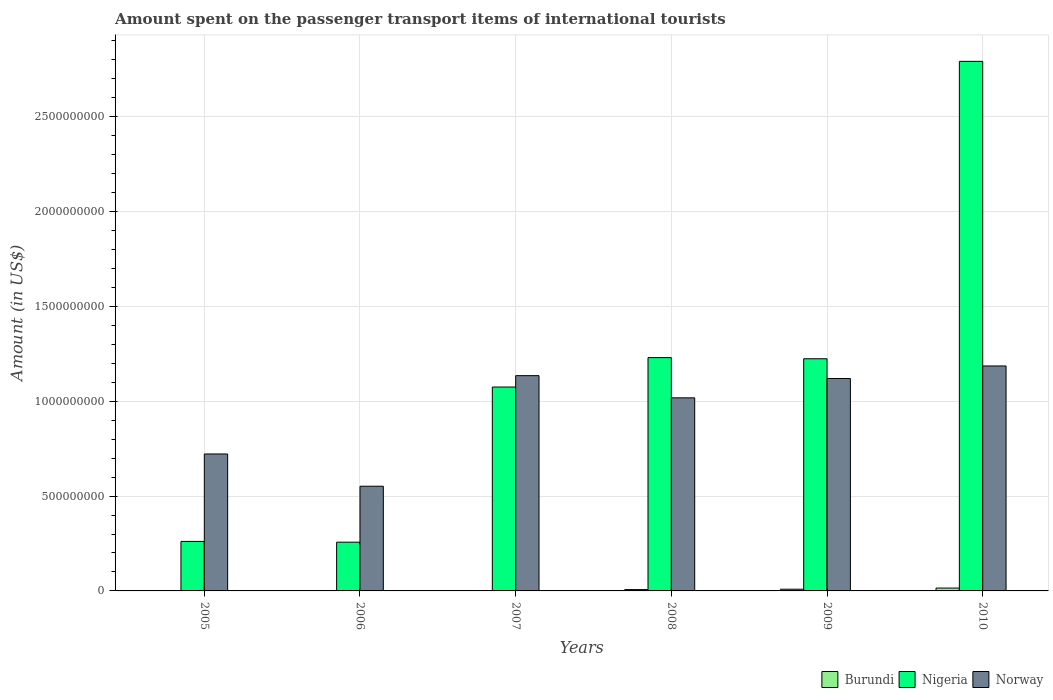How many different coloured bars are there?
Give a very brief answer. 3. Are the number of bars per tick equal to the number of legend labels?
Your response must be concise. Yes. What is the amount spent on the passenger transport items of international tourists in Burundi in 2007?
Keep it short and to the point. 2.00e+06. Across all years, what is the maximum amount spent on the passenger transport items of international tourists in Burundi?
Your response must be concise. 1.50e+07. Across all years, what is the minimum amount spent on the passenger transport items of international tourists in Burundi?
Give a very brief answer. 1.00e+06. In which year was the amount spent on the passenger transport items of international tourists in Burundi minimum?
Keep it short and to the point. 2006. What is the total amount spent on the passenger transport items of international tourists in Burundi in the graph?
Keep it short and to the point. 3.60e+07. What is the difference between the amount spent on the passenger transport items of international tourists in Nigeria in 2006 and that in 2010?
Keep it short and to the point. -2.54e+09. What is the difference between the amount spent on the passenger transport items of international tourists in Nigeria in 2008 and the amount spent on the passenger transport items of international tourists in Burundi in 2009?
Your answer should be very brief. 1.22e+09. What is the average amount spent on the passenger transport items of international tourists in Norway per year?
Provide a short and direct response. 9.56e+08. In the year 2009, what is the difference between the amount spent on the passenger transport items of international tourists in Burundi and amount spent on the passenger transport items of international tourists in Norway?
Offer a very short reply. -1.11e+09. In how many years, is the amount spent on the passenger transport items of international tourists in Norway greater than 1000000000 US$?
Provide a short and direct response. 4. What is the ratio of the amount spent on the passenger transport items of international tourists in Nigeria in 2005 to that in 2007?
Give a very brief answer. 0.24. Is the amount spent on the passenger transport items of international tourists in Nigeria in 2008 less than that in 2010?
Your answer should be compact. Yes. What is the difference between the highest and the lowest amount spent on the passenger transport items of international tourists in Nigeria?
Make the answer very short. 2.54e+09. Is the sum of the amount spent on the passenger transport items of international tourists in Norway in 2008 and 2010 greater than the maximum amount spent on the passenger transport items of international tourists in Nigeria across all years?
Give a very brief answer. No. What does the 2nd bar from the left in 2007 represents?
Provide a succinct answer. Nigeria. What does the 3rd bar from the right in 2010 represents?
Make the answer very short. Burundi. How many years are there in the graph?
Your answer should be very brief. 6. What is the difference between two consecutive major ticks on the Y-axis?
Your answer should be very brief. 5.00e+08. Does the graph contain any zero values?
Your answer should be compact. No. How are the legend labels stacked?
Provide a short and direct response. Horizontal. What is the title of the graph?
Make the answer very short. Amount spent on the passenger transport items of international tourists. Does "Burkina Faso" appear as one of the legend labels in the graph?
Give a very brief answer. No. What is the label or title of the Y-axis?
Your response must be concise. Amount (in US$). What is the Amount (in US$) of Nigeria in 2005?
Provide a short and direct response. 2.61e+08. What is the Amount (in US$) of Norway in 2005?
Ensure brevity in your answer.  7.22e+08. What is the Amount (in US$) of Burundi in 2006?
Keep it short and to the point. 1.00e+06. What is the Amount (in US$) in Nigeria in 2006?
Give a very brief answer. 2.57e+08. What is the Amount (in US$) in Norway in 2006?
Keep it short and to the point. 5.52e+08. What is the Amount (in US$) of Burundi in 2007?
Give a very brief answer. 2.00e+06. What is the Amount (in US$) of Nigeria in 2007?
Provide a short and direct response. 1.08e+09. What is the Amount (in US$) of Norway in 2007?
Offer a very short reply. 1.14e+09. What is the Amount (in US$) of Burundi in 2008?
Ensure brevity in your answer.  7.00e+06. What is the Amount (in US$) in Nigeria in 2008?
Offer a very short reply. 1.23e+09. What is the Amount (in US$) in Norway in 2008?
Your response must be concise. 1.02e+09. What is the Amount (in US$) in Burundi in 2009?
Make the answer very short. 9.00e+06. What is the Amount (in US$) of Nigeria in 2009?
Ensure brevity in your answer.  1.22e+09. What is the Amount (in US$) of Norway in 2009?
Ensure brevity in your answer.  1.12e+09. What is the Amount (in US$) of Burundi in 2010?
Give a very brief answer. 1.50e+07. What is the Amount (in US$) of Nigeria in 2010?
Keep it short and to the point. 2.79e+09. What is the Amount (in US$) in Norway in 2010?
Ensure brevity in your answer.  1.19e+09. Across all years, what is the maximum Amount (in US$) of Burundi?
Ensure brevity in your answer.  1.50e+07. Across all years, what is the maximum Amount (in US$) of Nigeria?
Make the answer very short. 2.79e+09. Across all years, what is the maximum Amount (in US$) of Norway?
Keep it short and to the point. 1.19e+09. Across all years, what is the minimum Amount (in US$) of Nigeria?
Your answer should be very brief. 2.57e+08. Across all years, what is the minimum Amount (in US$) of Norway?
Offer a terse response. 5.52e+08. What is the total Amount (in US$) in Burundi in the graph?
Your answer should be compact. 3.60e+07. What is the total Amount (in US$) of Nigeria in the graph?
Keep it short and to the point. 6.84e+09. What is the total Amount (in US$) of Norway in the graph?
Provide a short and direct response. 5.73e+09. What is the difference between the Amount (in US$) of Nigeria in 2005 and that in 2006?
Your answer should be compact. 4.00e+06. What is the difference between the Amount (in US$) in Norway in 2005 and that in 2006?
Your answer should be compact. 1.70e+08. What is the difference between the Amount (in US$) in Burundi in 2005 and that in 2007?
Offer a very short reply. 0. What is the difference between the Amount (in US$) of Nigeria in 2005 and that in 2007?
Your answer should be very brief. -8.14e+08. What is the difference between the Amount (in US$) in Norway in 2005 and that in 2007?
Offer a terse response. -4.13e+08. What is the difference between the Amount (in US$) in Burundi in 2005 and that in 2008?
Offer a terse response. -5.00e+06. What is the difference between the Amount (in US$) in Nigeria in 2005 and that in 2008?
Offer a terse response. -9.69e+08. What is the difference between the Amount (in US$) of Norway in 2005 and that in 2008?
Ensure brevity in your answer.  -2.96e+08. What is the difference between the Amount (in US$) in Burundi in 2005 and that in 2009?
Provide a succinct answer. -7.00e+06. What is the difference between the Amount (in US$) in Nigeria in 2005 and that in 2009?
Your answer should be very brief. -9.63e+08. What is the difference between the Amount (in US$) in Norway in 2005 and that in 2009?
Ensure brevity in your answer.  -3.98e+08. What is the difference between the Amount (in US$) of Burundi in 2005 and that in 2010?
Your answer should be very brief. -1.30e+07. What is the difference between the Amount (in US$) in Nigeria in 2005 and that in 2010?
Ensure brevity in your answer.  -2.53e+09. What is the difference between the Amount (in US$) in Norway in 2005 and that in 2010?
Offer a very short reply. -4.64e+08. What is the difference between the Amount (in US$) of Nigeria in 2006 and that in 2007?
Ensure brevity in your answer.  -8.18e+08. What is the difference between the Amount (in US$) in Norway in 2006 and that in 2007?
Provide a short and direct response. -5.83e+08. What is the difference between the Amount (in US$) in Burundi in 2006 and that in 2008?
Make the answer very short. -6.00e+06. What is the difference between the Amount (in US$) of Nigeria in 2006 and that in 2008?
Your response must be concise. -9.73e+08. What is the difference between the Amount (in US$) of Norway in 2006 and that in 2008?
Your answer should be compact. -4.66e+08. What is the difference between the Amount (in US$) of Burundi in 2006 and that in 2009?
Your answer should be very brief. -8.00e+06. What is the difference between the Amount (in US$) in Nigeria in 2006 and that in 2009?
Your answer should be very brief. -9.67e+08. What is the difference between the Amount (in US$) in Norway in 2006 and that in 2009?
Provide a succinct answer. -5.68e+08. What is the difference between the Amount (in US$) in Burundi in 2006 and that in 2010?
Provide a succinct answer. -1.40e+07. What is the difference between the Amount (in US$) in Nigeria in 2006 and that in 2010?
Offer a very short reply. -2.54e+09. What is the difference between the Amount (in US$) in Norway in 2006 and that in 2010?
Provide a succinct answer. -6.34e+08. What is the difference between the Amount (in US$) of Burundi in 2007 and that in 2008?
Your answer should be compact. -5.00e+06. What is the difference between the Amount (in US$) in Nigeria in 2007 and that in 2008?
Ensure brevity in your answer.  -1.55e+08. What is the difference between the Amount (in US$) of Norway in 2007 and that in 2008?
Provide a short and direct response. 1.17e+08. What is the difference between the Amount (in US$) in Burundi in 2007 and that in 2009?
Your answer should be very brief. -7.00e+06. What is the difference between the Amount (in US$) in Nigeria in 2007 and that in 2009?
Give a very brief answer. -1.49e+08. What is the difference between the Amount (in US$) of Norway in 2007 and that in 2009?
Ensure brevity in your answer.  1.50e+07. What is the difference between the Amount (in US$) in Burundi in 2007 and that in 2010?
Offer a terse response. -1.30e+07. What is the difference between the Amount (in US$) of Nigeria in 2007 and that in 2010?
Your answer should be very brief. -1.72e+09. What is the difference between the Amount (in US$) in Norway in 2007 and that in 2010?
Offer a very short reply. -5.10e+07. What is the difference between the Amount (in US$) of Nigeria in 2008 and that in 2009?
Make the answer very short. 6.00e+06. What is the difference between the Amount (in US$) in Norway in 2008 and that in 2009?
Make the answer very short. -1.02e+08. What is the difference between the Amount (in US$) of Burundi in 2008 and that in 2010?
Offer a very short reply. -8.00e+06. What is the difference between the Amount (in US$) in Nigeria in 2008 and that in 2010?
Your answer should be compact. -1.56e+09. What is the difference between the Amount (in US$) in Norway in 2008 and that in 2010?
Your answer should be compact. -1.68e+08. What is the difference between the Amount (in US$) in Burundi in 2009 and that in 2010?
Make the answer very short. -6.00e+06. What is the difference between the Amount (in US$) in Nigeria in 2009 and that in 2010?
Ensure brevity in your answer.  -1.57e+09. What is the difference between the Amount (in US$) in Norway in 2009 and that in 2010?
Your answer should be very brief. -6.60e+07. What is the difference between the Amount (in US$) of Burundi in 2005 and the Amount (in US$) of Nigeria in 2006?
Keep it short and to the point. -2.55e+08. What is the difference between the Amount (in US$) of Burundi in 2005 and the Amount (in US$) of Norway in 2006?
Offer a terse response. -5.50e+08. What is the difference between the Amount (in US$) in Nigeria in 2005 and the Amount (in US$) in Norway in 2006?
Keep it short and to the point. -2.91e+08. What is the difference between the Amount (in US$) in Burundi in 2005 and the Amount (in US$) in Nigeria in 2007?
Offer a very short reply. -1.07e+09. What is the difference between the Amount (in US$) in Burundi in 2005 and the Amount (in US$) in Norway in 2007?
Provide a short and direct response. -1.13e+09. What is the difference between the Amount (in US$) of Nigeria in 2005 and the Amount (in US$) of Norway in 2007?
Make the answer very short. -8.74e+08. What is the difference between the Amount (in US$) in Burundi in 2005 and the Amount (in US$) in Nigeria in 2008?
Offer a terse response. -1.23e+09. What is the difference between the Amount (in US$) in Burundi in 2005 and the Amount (in US$) in Norway in 2008?
Make the answer very short. -1.02e+09. What is the difference between the Amount (in US$) in Nigeria in 2005 and the Amount (in US$) in Norway in 2008?
Your response must be concise. -7.57e+08. What is the difference between the Amount (in US$) of Burundi in 2005 and the Amount (in US$) of Nigeria in 2009?
Provide a succinct answer. -1.22e+09. What is the difference between the Amount (in US$) of Burundi in 2005 and the Amount (in US$) of Norway in 2009?
Provide a succinct answer. -1.12e+09. What is the difference between the Amount (in US$) in Nigeria in 2005 and the Amount (in US$) in Norway in 2009?
Offer a very short reply. -8.59e+08. What is the difference between the Amount (in US$) of Burundi in 2005 and the Amount (in US$) of Nigeria in 2010?
Provide a short and direct response. -2.79e+09. What is the difference between the Amount (in US$) in Burundi in 2005 and the Amount (in US$) in Norway in 2010?
Offer a terse response. -1.18e+09. What is the difference between the Amount (in US$) in Nigeria in 2005 and the Amount (in US$) in Norway in 2010?
Provide a short and direct response. -9.25e+08. What is the difference between the Amount (in US$) in Burundi in 2006 and the Amount (in US$) in Nigeria in 2007?
Your answer should be very brief. -1.07e+09. What is the difference between the Amount (in US$) of Burundi in 2006 and the Amount (in US$) of Norway in 2007?
Your answer should be compact. -1.13e+09. What is the difference between the Amount (in US$) of Nigeria in 2006 and the Amount (in US$) of Norway in 2007?
Your response must be concise. -8.78e+08. What is the difference between the Amount (in US$) of Burundi in 2006 and the Amount (in US$) of Nigeria in 2008?
Your answer should be compact. -1.23e+09. What is the difference between the Amount (in US$) in Burundi in 2006 and the Amount (in US$) in Norway in 2008?
Ensure brevity in your answer.  -1.02e+09. What is the difference between the Amount (in US$) in Nigeria in 2006 and the Amount (in US$) in Norway in 2008?
Provide a short and direct response. -7.61e+08. What is the difference between the Amount (in US$) of Burundi in 2006 and the Amount (in US$) of Nigeria in 2009?
Make the answer very short. -1.22e+09. What is the difference between the Amount (in US$) of Burundi in 2006 and the Amount (in US$) of Norway in 2009?
Your answer should be compact. -1.12e+09. What is the difference between the Amount (in US$) in Nigeria in 2006 and the Amount (in US$) in Norway in 2009?
Provide a short and direct response. -8.63e+08. What is the difference between the Amount (in US$) in Burundi in 2006 and the Amount (in US$) in Nigeria in 2010?
Offer a very short reply. -2.79e+09. What is the difference between the Amount (in US$) in Burundi in 2006 and the Amount (in US$) in Norway in 2010?
Give a very brief answer. -1.18e+09. What is the difference between the Amount (in US$) in Nigeria in 2006 and the Amount (in US$) in Norway in 2010?
Offer a very short reply. -9.29e+08. What is the difference between the Amount (in US$) in Burundi in 2007 and the Amount (in US$) in Nigeria in 2008?
Provide a short and direct response. -1.23e+09. What is the difference between the Amount (in US$) of Burundi in 2007 and the Amount (in US$) of Norway in 2008?
Your answer should be very brief. -1.02e+09. What is the difference between the Amount (in US$) in Nigeria in 2007 and the Amount (in US$) in Norway in 2008?
Offer a terse response. 5.70e+07. What is the difference between the Amount (in US$) in Burundi in 2007 and the Amount (in US$) in Nigeria in 2009?
Keep it short and to the point. -1.22e+09. What is the difference between the Amount (in US$) in Burundi in 2007 and the Amount (in US$) in Norway in 2009?
Your answer should be compact. -1.12e+09. What is the difference between the Amount (in US$) in Nigeria in 2007 and the Amount (in US$) in Norway in 2009?
Your answer should be very brief. -4.50e+07. What is the difference between the Amount (in US$) in Burundi in 2007 and the Amount (in US$) in Nigeria in 2010?
Provide a short and direct response. -2.79e+09. What is the difference between the Amount (in US$) of Burundi in 2007 and the Amount (in US$) of Norway in 2010?
Your response must be concise. -1.18e+09. What is the difference between the Amount (in US$) of Nigeria in 2007 and the Amount (in US$) of Norway in 2010?
Your response must be concise. -1.11e+08. What is the difference between the Amount (in US$) in Burundi in 2008 and the Amount (in US$) in Nigeria in 2009?
Your response must be concise. -1.22e+09. What is the difference between the Amount (in US$) of Burundi in 2008 and the Amount (in US$) of Norway in 2009?
Offer a very short reply. -1.11e+09. What is the difference between the Amount (in US$) in Nigeria in 2008 and the Amount (in US$) in Norway in 2009?
Provide a succinct answer. 1.10e+08. What is the difference between the Amount (in US$) of Burundi in 2008 and the Amount (in US$) of Nigeria in 2010?
Make the answer very short. -2.78e+09. What is the difference between the Amount (in US$) of Burundi in 2008 and the Amount (in US$) of Norway in 2010?
Your answer should be very brief. -1.18e+09. What is the difference between the Amount (in US$) in Nigeria in 2008 and the Amount (in US$) in Norway in 2010?
Give a very brief answer. 4.40e+07. What is the difference between the Amount (in US$) of Burundi in 2009 and the Amount (in US$) of Nigeria in 2010?
Offer a terse response. -2.78e+09. What is the difference between the Amount (in US$) of Burundi in 2009 and the Amount (in US$) of Norway in 2010?
Your answer should be very brief. -1.18e+09. What is the difference between the Amount (in US$) in Nigeria in 2009 and the Amount (in US$) in Norway in 2010?
Your answer should be compact. 3.80e+07. What is the average Amount (in US$) in Burundi per year?
Make the answer very short. 6.00e+06. What is the average Amount (in US$) of Nigeria per year?
Offer a very short reply. 1.14e+09. What is the average Amount (in US$) of Norway per year?
Your answer should be very brief. 9.56e+08. In the year 2005, what is the difference between the Amount (in US$) in Burundi and Amount (in US$) in Nigeria?
Offer a terse response. -2.59e+08. In the year 2005, what is the difference between the Amount (in US$) of Burundi and Amount (in US$) of Norway?
Offer a terse response. -7.20e+08. In the year 2005, what is the difference between the Amount (in US$) of Nigeria and Amount (in US$) of Norway?
Make the answer very short. -4.61e+08. In the year 2006, what is the difference between the Amount (in US$) in Burundi and Amount (in US$) in Nigeria?
Make the answer very short. -2.56e+08. In the year 2006, what is the difference between the Amount (in US$) of Burundi and Amount (in US$) of Norway?
Give a very brief answer. -5.51e+08. In the year 2006, what is the difference between the Amount (in US$) in Nigeria and Amount (in US$) in Norway?
Give a very brief answer. -2.95e+08. In the year 2007, what is the difference between the Amount (in US$) of Burundi and Amount (in US$) of Nigeria?
Your response must be concise. -1.07e+09. In the year 2007, what is the difference between the Amount (in US$) in Burundi and Amount (in US$) in Norway?
Offer a very short reply. -1.13e+09. In the year 2007, what is the difference between the Amount (in US$) of Nigeria and Amount (in US$) of Norway?
Give a very brief answer. -6.00e+07. In the year 2008, what is the difference between the Amount (in US$) in Burundi and Amount (in US$) in Nigeria?
Offer a terse response. -1.22e+09. In the year 2008, what is the difference between the Amount (in US$) of Burundi and Amount (in US$) of Norway?
Provide a succinct answer. -1.01e+09. In the year 2008, what is the difference between the Amount (in US$) of Nigeria and Amount (in US$) of Norway?
Offer a very short reply. 2.12e+08. In the year 2009, what is the difference between the Amount (in US$) of Burundi and Amount (in US$) of Nigeria?
Make the answer very short. -1.22e+09. In the year 2009, what is the difference between the Amount (in US$) of Burundi and Amount (in US$) of Norway?
Give a very brief answer. -1.11e+09. In the year 2009, what is the difference between the Amount (in US$) in Nigeria and Amount (in US$) in Norway?
Provide a short and direct response. 1.04e+08. In the year 2010, what is the difference between the Amount (in US$) in Burundi and Amount (in US$) in Nigeria?
Keep it short and to the point. -2.78e+09. In the year 2010, what is the difference between the Amount (in US$) in Burundi and Amount (in US$) in Norway?
Make the answer very short. -1.17e+09. In the year 2010, what is the difference between the Amount (in US$) of Nigeria and Amount (in US$) of Norway?
Make the answer very short. 1.61e+09. What is the ratio of the Amount (in US$) in Nigeria in 2005 to that in 2006?
Ensure brevity in your answer.  1.02. What is the ratio of the Amount (in US$) of Norway in 2005 to that in 2006?
Offer a terse response. 1.31. What is the ratio of the Amount (in US$) of Burundi in 2005 to that in 2007?
Give a very brief answer. 1. What is the ratio of the Amount (in US$) of Nigeria in 2005 to that in 2007?
Your answer should be very brief. 0.24. What is the ratio of the Amount (in US$) of Norway in 2005 to that in 2007?
Offer a terse response. 0.64. What is the ratio of the Amount (in US$) of Burundi in 2005 to that in 2008?
Your response must be concise. 0.29. What is the ratio of the Amount (in US$) of Nigeria in 2005 to that in 2008?
Offer a very short reply. 0.21. What is the ratio of the Amount (in US$) in Norway in 2005 to that in 2008?
Your answer should be very brief. 0.71. What is the ratio of the Amount (in US$) of Burundi in 2005 to that in 2009?
Provide a short and direct response. 0.22. What is the ratio of the Amount (in US$) in Nigeria in 2005 to that in 2009?
Offer a very short reply. 0.21. What is the ratio of the Amount (in US$) of Norway in 2005 to that in 2009?
Make the answer very short. 0.64. What is the ratio of the Amount (in US$) in Burundi in 2005 to that in 2010?
Provide a short and direct response. 0.13. What is the ratio of the Amount (in US$) of Nigeria in 2005 to that in 2010?
Your answer should be compact. 0.09. What is the ratio of the Amount (in US$) of Norway in 2005 to that in 2010?
Give a very brief answer. 0.61. What is the ratio of the Amount (in US$) in Burundi in 2006 to that in 2007?
Offer a very short reply. 0.5. What is the ratio of the Amount (in US$) of Nigeria in 2006 to that in 2007?
Keep it short and to the point. 0.24. What is the ratio of the Amount (in US$) of Norway in 2006 to that in 2007?
Your response must be concise. 0.49. What is the ratio of the Amount (in US$) in Burundi in 2006 to that in 2008?
Your answer should be very brief. 0.14. What is the ratio of the Amount (in US$) of Nigeria in 2006 to that in 2008?
Ensure brevity in your answer.  0.21. What is the ratio of the Amount (in US$) of Norway in 2006 to that in 2008?
Offer a very short reply. 0.54. What is the ratio of the Amount (in US$) of Burundi in 2006 to that in 2009?
Provide a short and direct response. 0.11. What is the ratio of the Amount (in US$) of Nigeria in 2006 to that in 2009?
Your response must be concise. 0.21. What is the ratio of the Amount (in US$) of Norway in 2006 to that in 2009?
Offer a terse response. 0.49. What is the ratio of the Amount (in US$) in Burundi in 2006 to that in 2010?
Provide a short and direct response. 0.07. What is the ratio of the Amount (in US$) of Nigeria in 2006 to that in 2010?
Make the answer very short. 0.09. What is the ratio of the Amount (in US$) in Norway in 2006 to that in 2010?
Your answer should be very brief. 0.47. What is the ratio of the Amount (in US$) of Burundi in 2007 to that in 2008?
Make the answer very short. 0.29. What is the ratio of the Amount (in US$) of Nigeria in 2007 to that in 2008?
Give a very brief answer. 0.87. What is the ratio of the Amount (in US$) of Norway in 2007 to that in 2008?
Your answer should be very brief. 1.11. What is the ratio of the Amount (in US$) of Burundi in 2007 to that in 2009?
Provide a succinct answer. 0.22. What is the ratio of the Amount (in US$) in Nigeria in 2007 to that in 2009?
Your response must be concise. 0.88. What is the ratio of the Amount (in US$) of Norway in 2007 to that in 2009?
Ensure brevity in your answer.  1.01. What is the ratio of the Amount (in US$) of Burundi in 2007 to that in 2010?
Provide a short and direct response. 0.13. What is the ratio of the Amount (in US$) of Nigeria in 2007 to that in 2010?
Make the answer very short. 0.39. What is the ratio of the Amount (in US$) of Norway in 2007 to that in 2010?
Give a very brief answer. 0.96. What is the ratio of the Amount (in US$) of Nigeria in 2008 to that in 2009?
Offer a very short reply. 1. What is the ratio of the Amount (in US$) of Norway in 2008 to that in 2009?
Offer a terse response. 0.91. What is the ratio of the Amount (in US$) in Burundi in 2008 to that in 2010?
Provide a short and direct response. 0.47. What is the ratio of the Amount (in US$) in Nigeria in 2008 to that in 2010?
Make the answer very short. 0.44. What is the ratio of the Amount (in US$) in Norway in 2008 to that in 2010?
Make the answer very short. 0.86. What is the ratio of the Amount (in US$) in Nigeria in 2009 to that in 2010?
Offer a terse response. 0.44. What is the difference between the highest and the second highest Amount (in US$) of Burundi?
Keep it short and to the point. 6.00e+06. What is the difference between the highest and the second highest Amount (in US$) of Nigeria?
Make the answer very short. 1.56e+09. What is the difference between the highest and the second highest Amount (in US$) of Norway?
Keep it short and to the point. 5.10e+07. What is the difference between the highest and the lowest Amount (in US$) of Burundi?
Provide a succinct answer. 1.40e+07. What is the difference between the highest and the lowest Amount (in US$) of Nigeria?
Ensure brevity in your answer.  2.54e+09. What is the difference between the highest and the lowest Amount (in US$) of Norway?
Provide a short and direct response. 6.34e+08. 